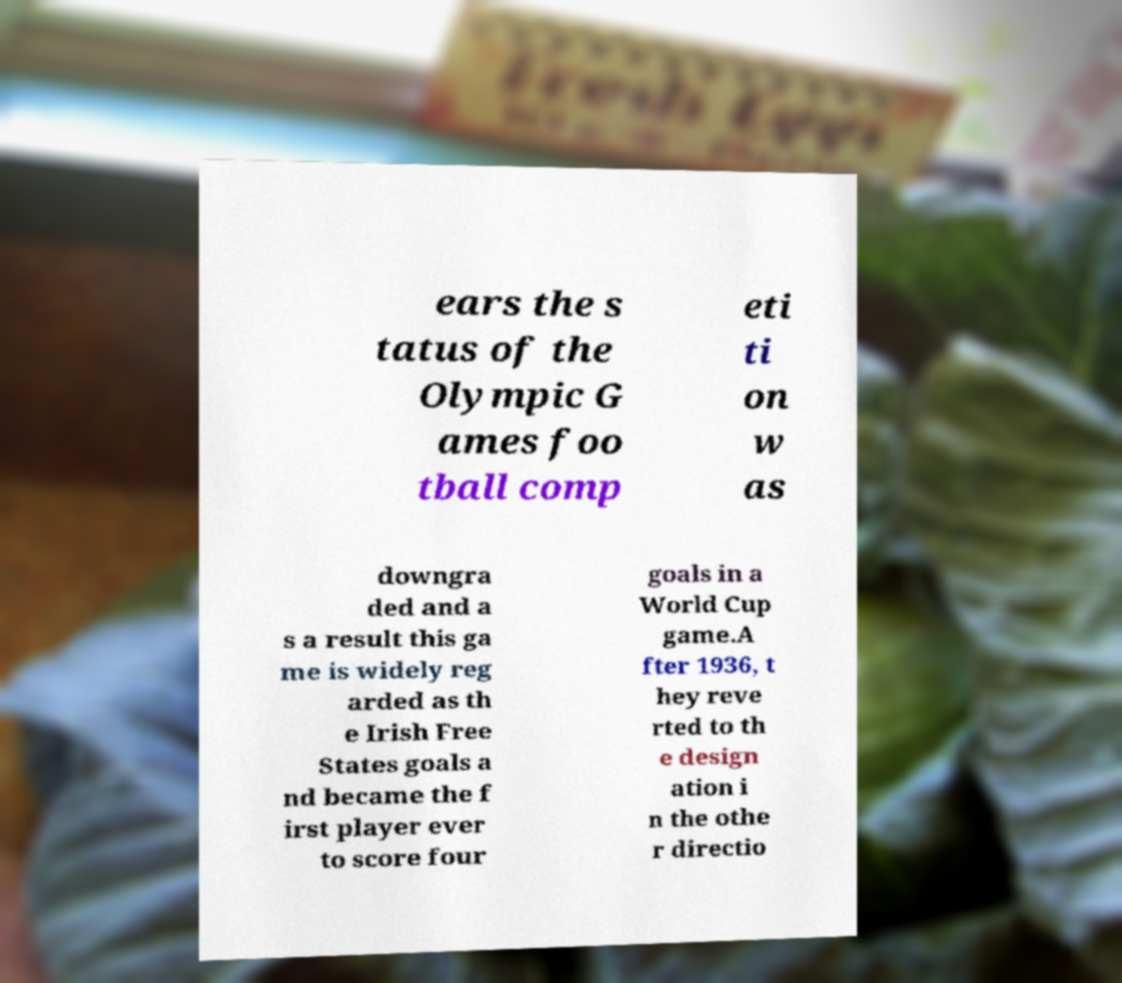What messages or text are displayed in this image? I need them in a readable, typed format. ears the s tatus of the Olympic G ames foo tball comp eti ti on w as downgra ded and a s a result this ga me is widely reg arded as th e Irish Free States goals a nd became the f irst player ever to score four goals in a World Cup game.A fter 1936, t hey reve rted to th e design ation i n the othe r directio 